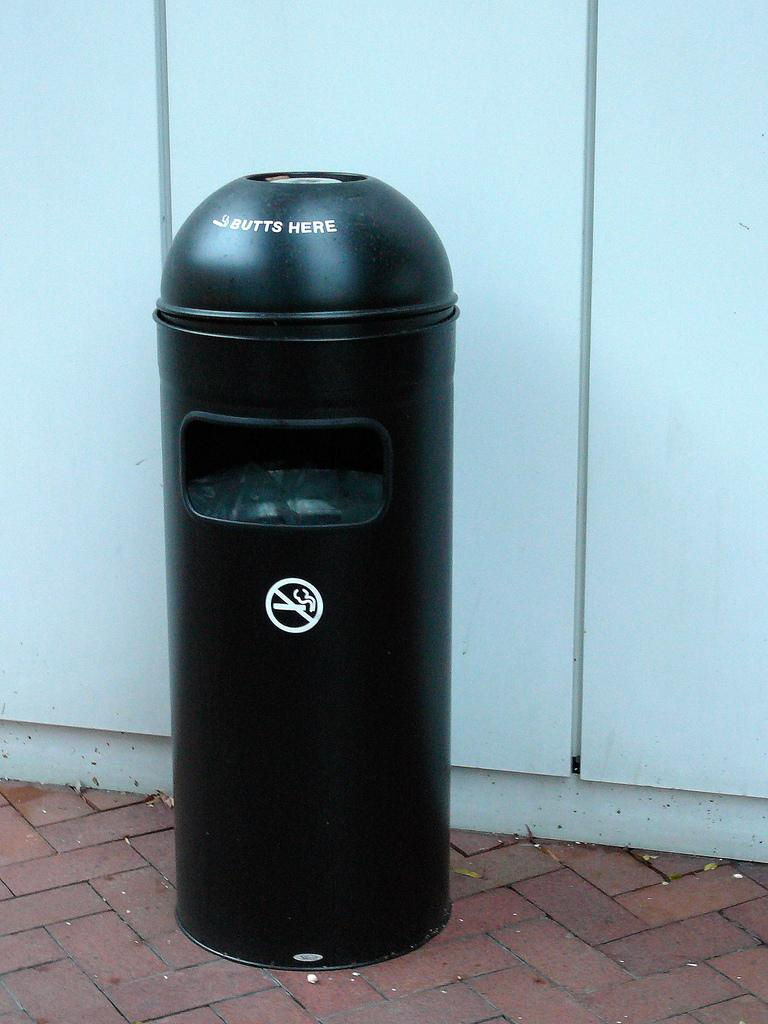<image>
Render a clear and concise summary of the photo. A trash can telling you to put cigarette butts here. 